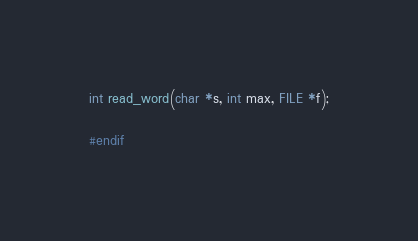Convert code to text. <code><loc_0><loc_0><loc_500><loc_500><_C_>
int read_word(char *s, int max, FILE *f);

#endif</code> 